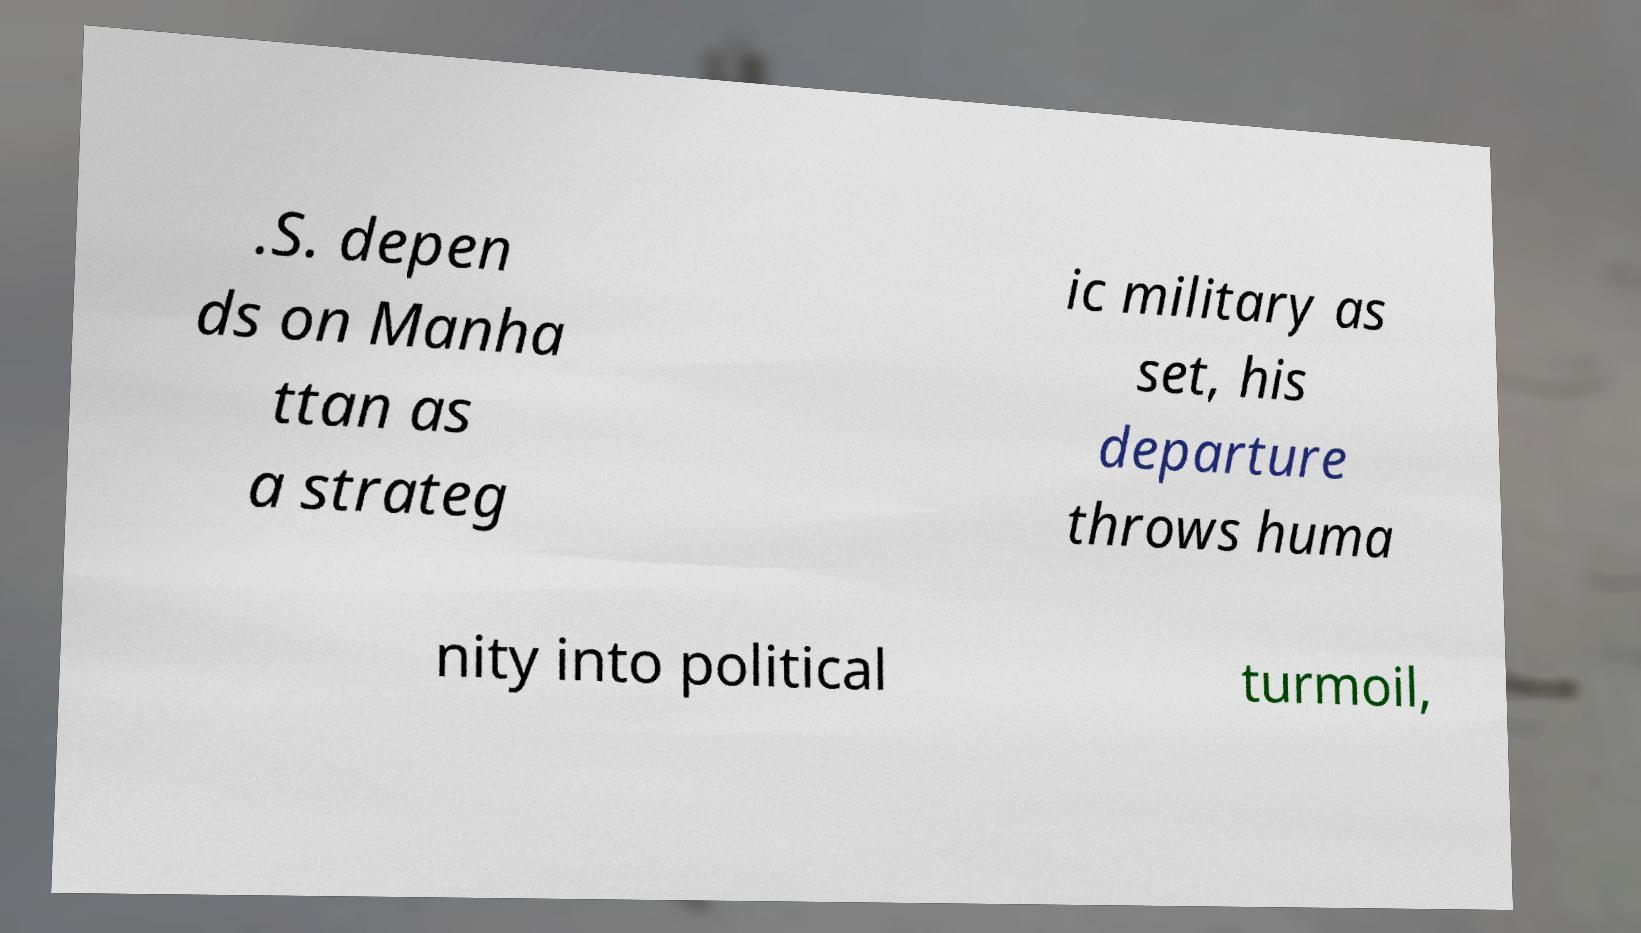There's text embedded in this image that I need extracted. Can you transcribe it verbatim? .S. depen ds on Manha ttan as a strateg ic military as set, his departure throws huma nity into political turmoil, 